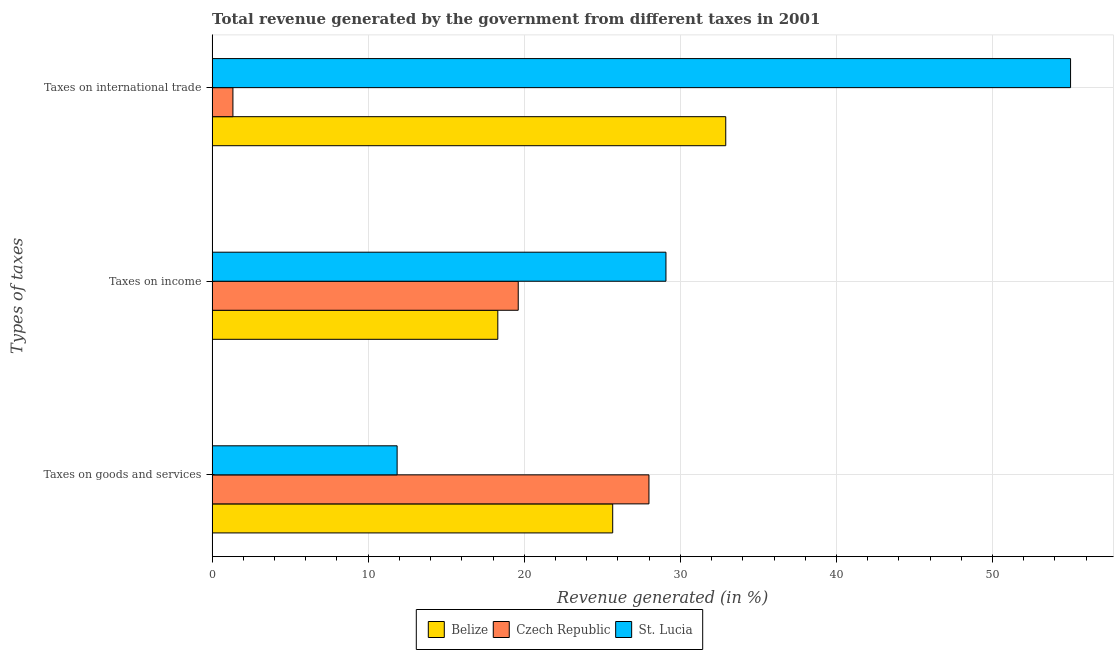Are the number of bars on each tick of the Y-axis equal?
Offer a terse response. Yes. How many bars are there on the 3rd tick from the bottom?
Give a very brief answer. 3. What is the label of the 3rd group of bars from the top?
Make the answer very short. Taxes on goods and services. What is the percentage of revenue generated by tax on international trade in St. Lucia?
Offer a terse response. 55. Across all countries, what is the maximum percentage of revenue generated by taxes on goods and services?
Provide a succinct answer. 27.99. Across all countries, what is the minimum percentage of revenue generated by taxes on goods and services?
Offer a terse response. 11.85. In which country was the percentage of revenue generated by tax on international trade maximum?
Ensure brevity in your answer.  St. Lucia. In which country was the percentage of revenue generated by taxes on goods and services minimum?
Ensure brevity in your answer.  St. Lucia. What is the total percentage of revenue generated by taxes on income in the graph?
Provide a succinct answer. 67. What is the difference between the percentage of revenue generated by tax on international trade in St. Lucia and that in Belize?
Your response must be concise. 22.09. What is the difference between the percentage of revenue generated by taxes on income in Czech Republic and the percentage of revenue generated by tax on international trade in Belize?
Offer a terse response. -13.3. What is the average percentage of revenue generated by taxes on income per country?
Keep it short and to the point. 22.33. What is the difference between the percentage of revenue generated by taxes on goods and services and percentage of revenue generated by tax on international trade in St. Lucia?
Your response must be concise. -43.15. In how many countries, is the percentage of revenue generated by taxes on goods and services greater than 26 %?
Offer a very short reply. 1. What is the ratio of the percentage of revenue generated by tax on international trade in Czech Republic to that in St. Lucia?
Your response must be concise. 0.02. What is the difference between the highest and the second highest percentage of revenue generated by tax on international trade?
Provide a succinct answer. 22.09. What is the difference between the highest and the lowest percentage of revenue generated by taxes on goods and services?
Offer a very short reply. 16.14. What does the 2nd bar from the top in Taxes on income represents?
Make the answer very short. Czech Republic. What does the 3rd bar from the bottom in Taxes on international trade represents?
Provide a succinct answer. St. Lucia. Is it the case that in every country, the sum of the percentage of revenue generated by taxes on goods and services and percentage of revenue generated by taxes on income is greater than the percentage of revenue generated by tax on international trade?
Give a very brief answer. No. Are all the bars in the graph horizontal?
Ensure brevity in your answer.  Yes. What is the difference between two consecutive major ticks on the X-axis?
Offer a terse response. 10. Are the values on the major ticks of X-axis written in scientific E-notation?
Provide a short and direct response. No. Where does the legend appear in the graph?
Provide a short and direct response. Bottom center. What is the title of the graph?
Ensure brevity in your answer.  Total revenue generated by the government from different taxes in 2001. What is the label or title of the X-axis?
Your answer should be very brief. Revenue generated (in %). What is the label or title of the Y-axis?
Offer a very short reply. Types of taxes. What is the Revenue generated (in %) of Belize in Taxes on goods and services?
Your answer should be compact. 25.67. What is the Revenue generated (in %) of Czech Republic in Taxes on goods and services?
Provide a short and direct response. 27.99. What is the Revenue generated (in %) in St. Lucia in Taxes on goods and services?
Provide a short and direct response. 11.85. What is the Revenue generated (in %) of Belize in Taxes on income?
Your answer should be very brief. 18.3. What is the Revenue generated (in %) of Czech Republic in Taxes on income?
Offer a terse response. 19.61. What is the Revenue generated (in %) in St. Lucia in Taxes on income?
Provide a succinct answer. 29.08. What is the Revenue generated (in %) of Belize in Taxes on international trade?
Offer a very short reply. 32.91. What is the Revenue generated (in %) of Czech Republic in Taxes on international trade?
Your answer should be very brief. 1.33. What is the Revenue generated (in %) in St. Lucia in Taxes on international trade?
Your answer should be very brief. 55. Across all Types of taxes, what is the maximum Revenue generated (in %) in Belize?
Ensure brevity in your answer.  32.91. Across all Types of taxes, what is the maximum Revenue generated (in %) of Czech Republic?
Make the answer very short. 27.99. Across all Types of taxes, what is the maximum Revenue generated (in %) in St. Lucia?
Provide a short and direct response. 55. Across all Types of taxes, what is the minimum Revenue generated (in %) in Belize?
Provide a short and direct response. 18.3. Across all Types of taxes, what is the minimum Revenue generated (in %) in Czech Republic?
Your response must be concise. 1.33. Across all Types of taxes, what is the minimum Revenue generated (in %) in St. Lucia?
Make the answer very short. 11.85. What is the total Revenue generated (in %) in Belize in the graph?
Offer a very short reply. 76.88. What is the total Revenue generated (in %) of Czech Republic in the graph?
Ensure brevity in your answer.  48.94. What is the total Revenue generated (in %) in St. Lucia in the graph?
Your answer should be very brief. 95.93. What is the difference between the Revenue generated (in %) in Belize in Taxes on goods and services and that in Taxes on income?
Offer a very short reply. 7.36. What is the difference between the Revenue generated (in %) in Czech Republic in Taxes on goods and services and that in Taxes on income?
Ensure brevity in your answer.  8.38. What is the difference between the Revenue generated (in %) of St. Lucia in Taxes on goods and services and that in Taxes on income?
Provide a short and direct response. -17.22. What is the difference between the Revenue generated (in %) of Belize in Taxes on goods and services and that in Taxes on international trade?
Your answer should be compact. -7.24. What is the difference between the Revenue generated (in %) in Czech Republic in Taxes on goods and services and that in Taxes on international trade?
Make the answer very short. 26.66. What is the difference between the Revenue generated (in %) in St. Lucia in Taxes on goods and services and that in Taxes on international trade?
Ensure brevity in your answer.  -43.15. What is the difference between the Revenue generated (in %) in Belize in Taxes on income and that in Taxes on international trade?
Provide a succinct answer. -14.6. What is the difference between the Revenue generated (in %) of Czech Republic in Taxes on income and that in Taxes on international trade?
Provide a short and direct response. 18.28. What is the difference between the Revenue generated (in %) in St. Lucia in Taxes on income and that in Taxes on international trade?
Provide a succinct answer. -25.92. What is the difference between the Revenue generated (in %) in Belize in Taxes on goods and services and the Revenue generated (in %) in Czech Republic in Taxes on income?
Provide a short and direct response. 6.05. What is the difference between the Revenue generated (in %) in Belize in Taxes on goods and services and the Revenue generated (in %) in St. Lucia in Taxes on income?
Provide a succinct answer. -3.41. What is the difference between the Revenue generated (in %) in Czech Republic in Taxes on goods and services and the Revenue generated (in %) in St. Lucia in Taxes on income?
Make the answer very short. -1.09. What is the difference between the Revenue generated (in %) in Belize in Taxes on goods and services and the Revenue generated (in %) in Czech Republic in Taxes on international trade?
Make the answer very short. 24.33. What is the difference between the Revenue generated (in %) in Belize in Taxes on goods and services and the Revenue generated (in %) in St. Lucia in Taxes on international trade?
Offer a terse response. -29.34. What is the difference between the Revenue generated (in %) in Czech Republic in Taxes on goods and services and the Revenue generated (in %) in St. Lucia in Taxes on international trade?
Ensure brevity in your answer.  -27.01. What is the difference between the Revenue generated (in %) of Belize in Taxes on income and the Revenue generated (in %) of Czech Republic in Taxes on international trade?
Ensure brevity in your answer.  16.97. What is the difference between the Revenue generated (in %) in Belize in Taxes on income and the Revenue generated (in %) in St. Lucia in Taxes on international trade?
Give a very brief answer. -36.7. What is the difference between the Revenue generated (in %) of Czech Republic in Taxes on income and the Revenue generated (in %) of St. Lucia in Taxes on international trade?
Offer a terse response. -35.39. What is the average Revenue generated (in %) of Belize per Types of taxes?
Offer a terse response. 25.63. What is the average Revenue generated (in %) in Czech Republic per Types of taxes?
Provide a short and direct response. 16.31. What is the average Revenue generated (in %) of St. Lucia per Types of taxes?
Your answer should be compact. 31.98. What is the difference between the Revenue generated (in %) of Belize and Revenue generated (in %) of Czech Republic in Taxes on goods and services?
Your answer should be very brief. -2.32. What is the difference between the Revenue generated (in %) of Belize and Revenue generated (in %) of St. Lucia in Taxes on goods and services?
Provide a succinct answer. 13.81. What is the difference between the Revenue generated (in %) in Czech Republic and Revenue generated (in %) in St. Lucia in Taxes on goods and services?
Your answer should be very brief. 16.14. What is the difference between the Revenue generated (in %) in Belize and Revenue generated (in %) in Czech Republic in Taxes on income?
Give a very brief answer. -1.31. What is the difference between the Revenue generated (in %) of Belize and Revenue generated (in %) of St. Lucia in Taxes on income?
Ensure brevity in your answer.  -10.77. What is the difference between the Revenue generated (in %) of Czech Republic and Revenue generated (in %) of St. Lucia in Taxes on income?
Your answer should be compact. -9.46. What is the difference between the Revenue generated (in %) of Belize and Revenue generated (in %) of Czech Republic in Taxes on international trade?
Give a very brief answer. 31.58. What is the difference between the Revenue generated (in %) of Belize and Revenue generated (in %) of St. Lucia in Taxes on international trade?
Offer a very short reply. -22.09. What is the difference between the Revenue generated (in %) in Czech Republic and Revenue generated (in %) in St. Lucia in Taxes on international trade?
Give a very brief answer. -53.67. What is the ratio of the Revenue generated (in %) in Belize in Taxes on goods and services to that in Taxes on income?
Keep it short and to the point. 1.4. What is the ratio of the Revenue generated (in %) of Czech Republic in Taxes on goods and services to that in Taxes on income?
Offer a very short reply. 1.43. What is the ratio of the Revenue generated (in %) in St. Lucia in Taxes on goods and services to that in Taxes on income?
Provide a succinct answer. 0.41. What is the ratio of the Revenue generated (in %) of Belize in Taxes on goods and services to that in Taxes on international trade?
Provide a succinct answer. 0.78. What is the ratio of the Revenue generated (in %) of Czech Republic in Taxes on goods and services to that in Taxes on international trade?
Make the answer very short. 21. What is the ratio of the Revenue generated (in %) in St. Lucia in Taxes on goods and services to that in Taxes on international trade?
Your response must be concise. 0.22. What is the ratio of the Revenue generated (in %) of Belize in Taxes on income to that in Taxes on international trade?
Offer a very short reply. 0.56. What is the ratio of the Revenue generated (in %) in Czech Republic in Taxes on income to that in Taxes on international trade?
Keep it short and to the point. 14.72. What is the ratio of the Revenue generated (in %) of St. Lucia in Taxes on income to that in Taxes on international trade?
Your answer should be compact. 0.53. What is the difference between the highest and the second highest Revenue generated (in %) in Belize?
Provide a short and direct response. 7.24. What is the difference between the highest and the second highest Revenue generated (in %) in Czech Republic?
Keep it short and to the point. 8.38. What is the difference between the highest and the second highest Revenue generated (in %) in St. Lucia?
Your response must be concise. 25.92. What is the difference between the highest and the lowest Revenue generated (in %) of Belize?
Provide a short and direct response. 14.6. What is the difference between the highest and the lowest Revenue generated (in %) in Czech Republic?
Make the answer very short. 26.66. What is the difference between the highest and the lowest Revenue generated (in %) of St. Lucia?
Your answer should be compact. 43.15. 